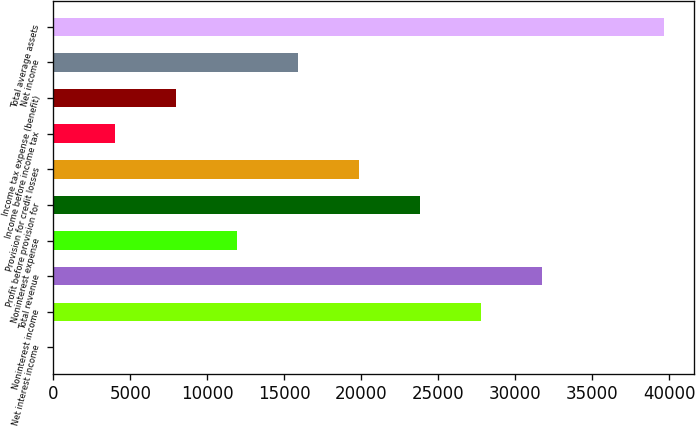Convert chart. <chart><loc_0><loc_0><loc_500><loc_500><bar_chart><fcel>Net interest income<fcel>Noninterest income<fcel>Total revenue<fcel>Noninterest expense<fcel>Profit before provision for<fcel>Provision for credit losses<fcel>Income before income tax<fcel>Income tax expense (benefit)<fcel>Net income<fcel>Total average assets<nl><fcel>27<fcel>27753.3<fcel>31714.2<fcel>11909.7<fcel>23792.4<fcel>19831.5<fcel>3987.9<fcel>7948.8<fcel>15870.6<fcel>39636<nl></chart> 